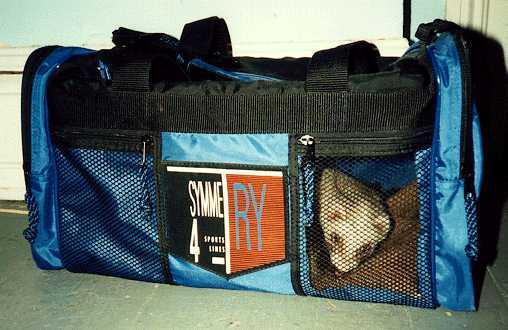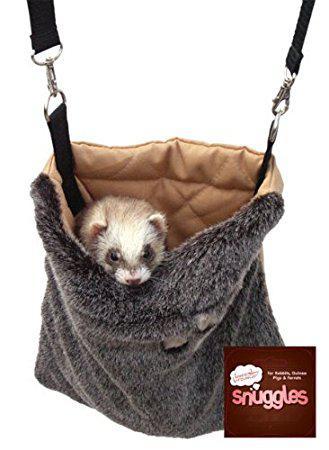The first image is the image on the left, the second image is the image on the right. Assess this claim about the two images: "There is a gray pouch with a brown inner lining containing a ferret.". Correct or not? Answer yes or no. Yes. 